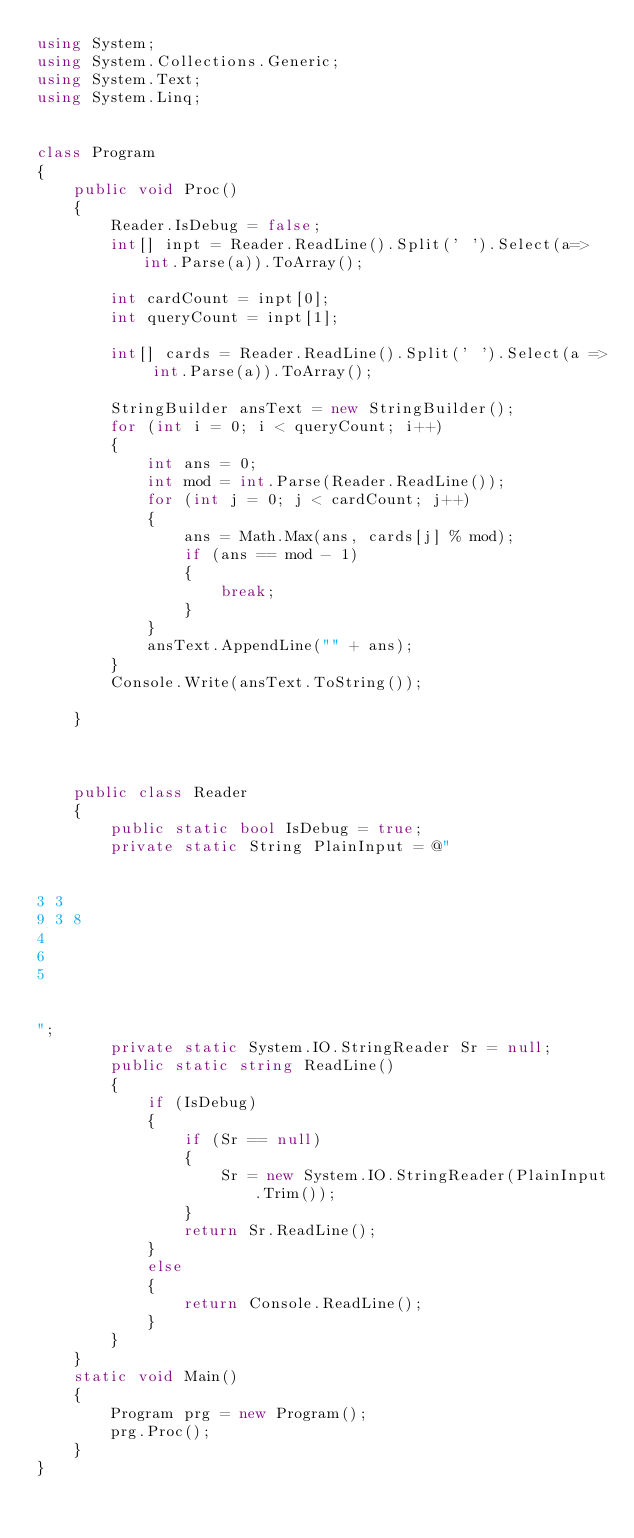Convert code to text. <code><loc_0><loc_0><loc_500><loc_500><_C#_>using System;
using System.Collections.Generic;
using System.Text;
using System.Linq;


class Program
{
    public void Proc()
    {
        Reader.IsDebug = false;
        int[] inpt = Reader.ReadLine().Split(' ').Select(a=>int.Parse(a)).ToArray();

        int cardCount = inpt[0];
        int queryCount = inpt[1];

        int[] cards = Reader.ReadLine().Split(' ').Select(a => int.Parse(a)).ToArray();

        StringBuilder ansText = new StringBuilder();
        for (int i = 0; i < queryCount; i++)
        {
            int ans = 0;
            int mod = int.Parse(Reader.ReadLine());
            for (int j = 0; j < cardCount; j++)
            {
                ans = Math.Max(ans, cards[j] % mod);
                if (ans == mod - 1)
                {
                    break;
                }
            }
            ansText.AppendLine("" + ans);
        }
        Console.Write(ansText.ToString());

    }



    public class Reader
    {
        public static bool IsDebug = true;
        private static String PlainInput = @"


3 3
9 3 8
4
6
5


";
        private static System.IO.StringReader Sr = null;
        public static string ReadLine()
        {
            if (IsDebug)
            {
                if (Sr == null)
                {
                    Sr = new System.IO.StringReader(PlainInput.Trim());
                }
                return Sr.ReadLine();
            }
            else
            {
                return Console.ReadLine();
            }
        }
    }
    static void Main()
    {
        Program prg = new Program();
        prg.Proc();
    }
}</code> 